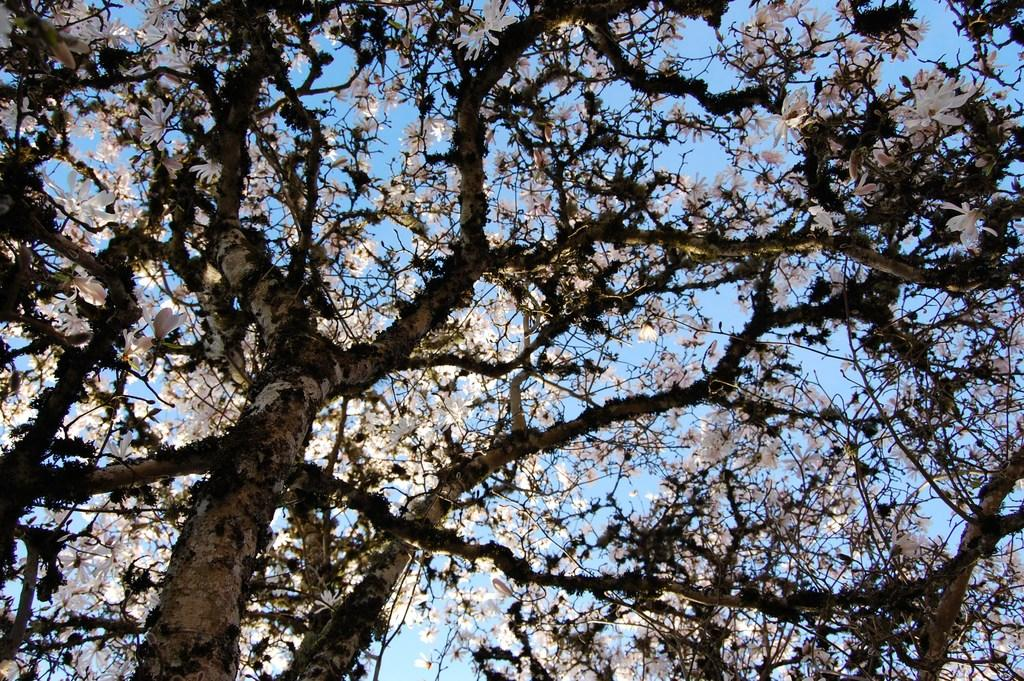What is the main subject of the image? The main subject of the image is a tree. What can be observed about the tree's appearance? The tree has white flowers. What can be seen in the background of the image? The sky is visible in the background of the image. What theory is being discussed by the tree in the image? There is no discussion or theory present in the image, as it features a tree with white flowers and a visible sky in the background. Can you see a bottle hanging from the tree in the image? There is no bottle present in the image; it only features a tree with white flowers and a visible sky in the background. 